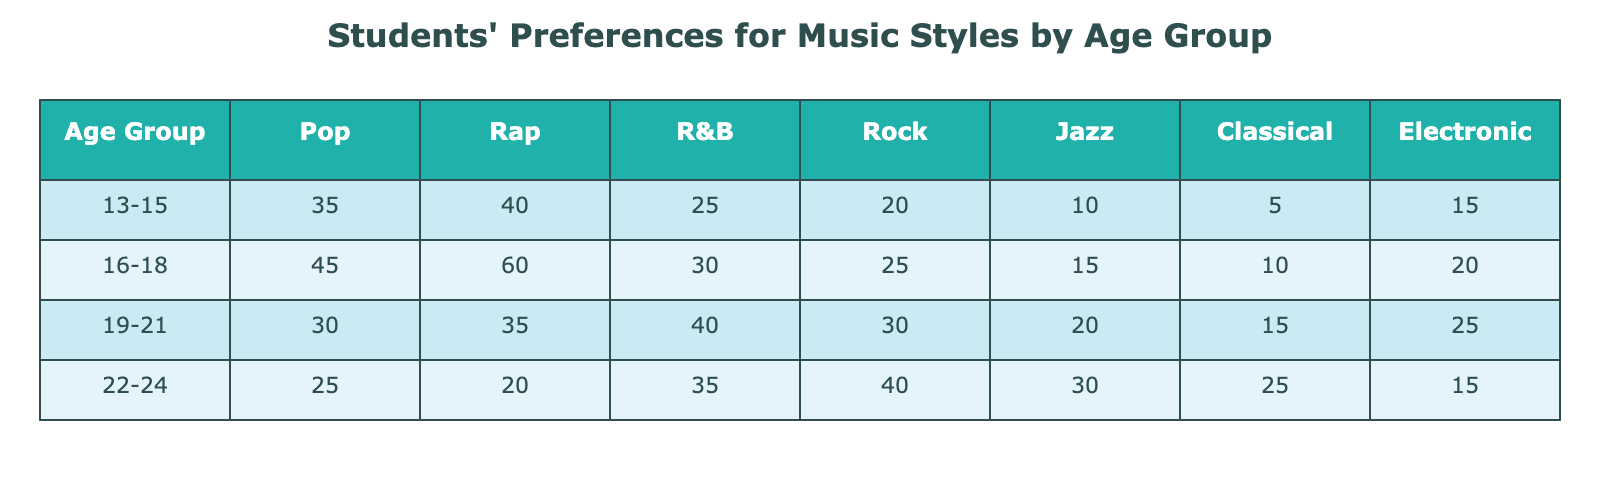What is the number of students aged 19-21 who prefer Rock music? From the table, we can look at the row for the age group 19-21. The number of students who prefer Rock in this age group is 30.
Answer: 30 What style of music is the most preferred among students aged 16-18? Referring to the 16-18 age group in the table, the highest number is for Rap music, with 60 students preferring it.
Answer: Rap What is the total number of students who prefer Jazz music across all age groups? We sum the Jazz preferences for each age group: 10 (13-15) + 15 (16-18) + 20 (19-21) + 30 (22-24) = 75.
Answer: 75 Is there a greater number of students preferring Pop music in the age group 13-15 compared to those preferring Classical in the same age group? Checking the table, 35 students prefer Pop while only 5 prefer Classical in the 13-15 age group. Thus, it is true that more students prefer Pop.
Answer: Yes What is the average preference for Electronic music among students aged 16-18 and 22-24? For the two age groups: 20 (16-18) and 15 (22-24). The average is (20 + 15) / 2 = 17.5.
Answer: 17.5 Are there more students in the 19-21 age group preferring R&B than in the 22-24 age group? The number of students preferring R&B is 40 in the 19-21 group and 35 in the 22-24 group. Therefore, the statement is true.
Answer: Yes What is the difference in the number of students preferring Electronic music between the age groups 19-21 and 22-24? In the 19-21 age group, 25 students prefer Electronic music and in the 22-24 age group, 15 students prefer it. The difference is 25 - 15 = 10.
Answer: 10 Which age group has the least preference for Classical music? Looking at the table, the age group 13-15 has the least preference for Classical music with only 5 students.
Answer: 13-15 What is the total number of students aged 22-24 who prefer either Rock or Jazz? From the row for 22-24, Rock has 40 students and Jazz has 30 students. Adding them gives us 40 + 30 = 70.
Answer: 70 